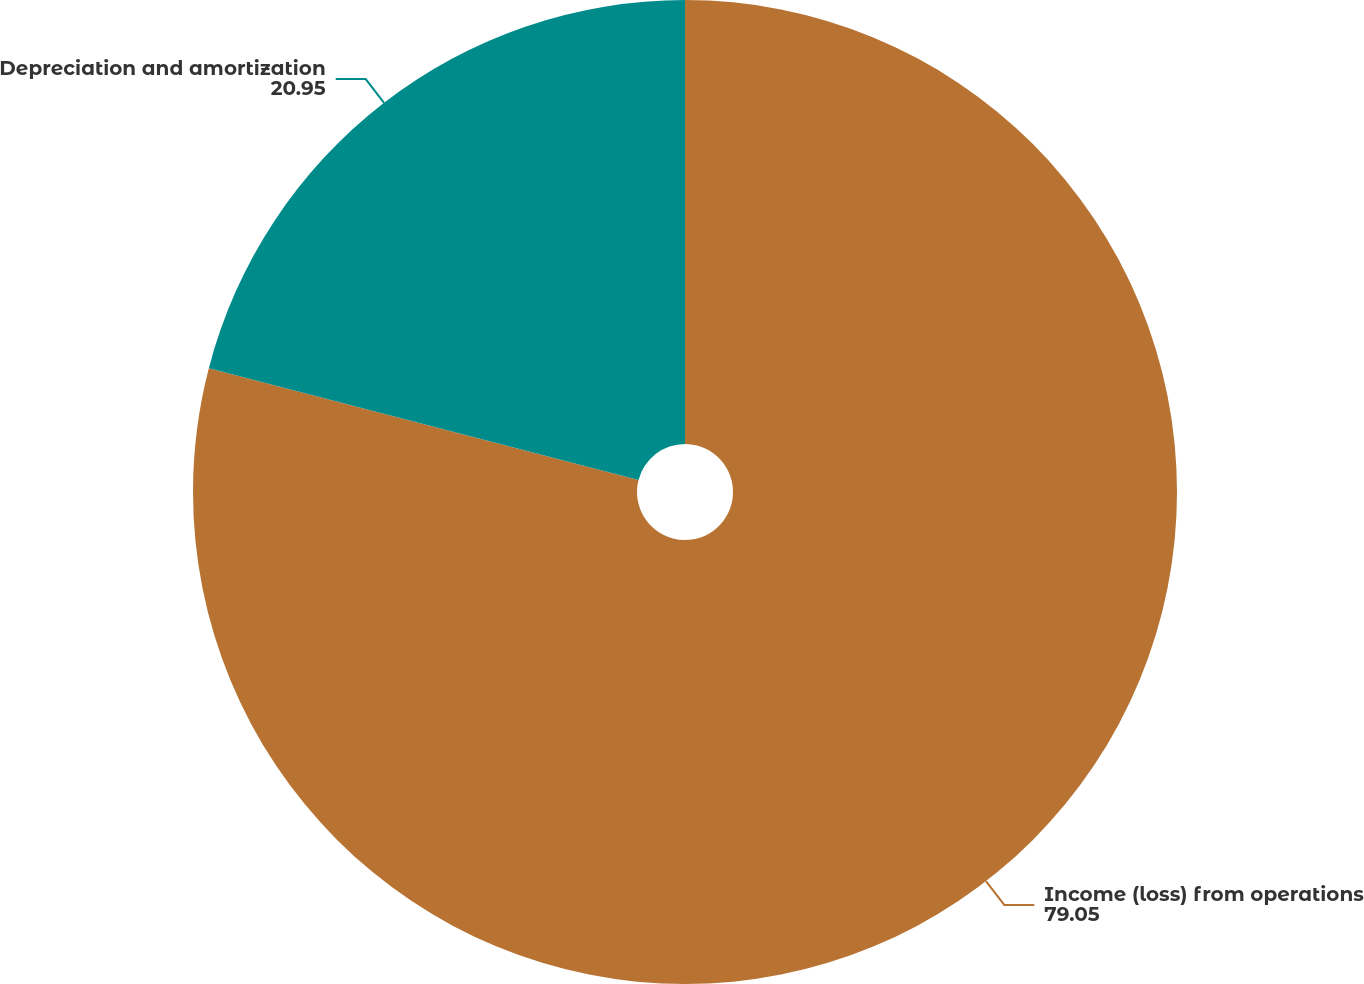<chart> <loc_0><loc_0><loc_500><loc_500><pie_chart><fcel>Income (loss) from operations<fcel>Depreciation and amortization<nl><fcel>79.05%<fcel>20.95%<nl></chart> 